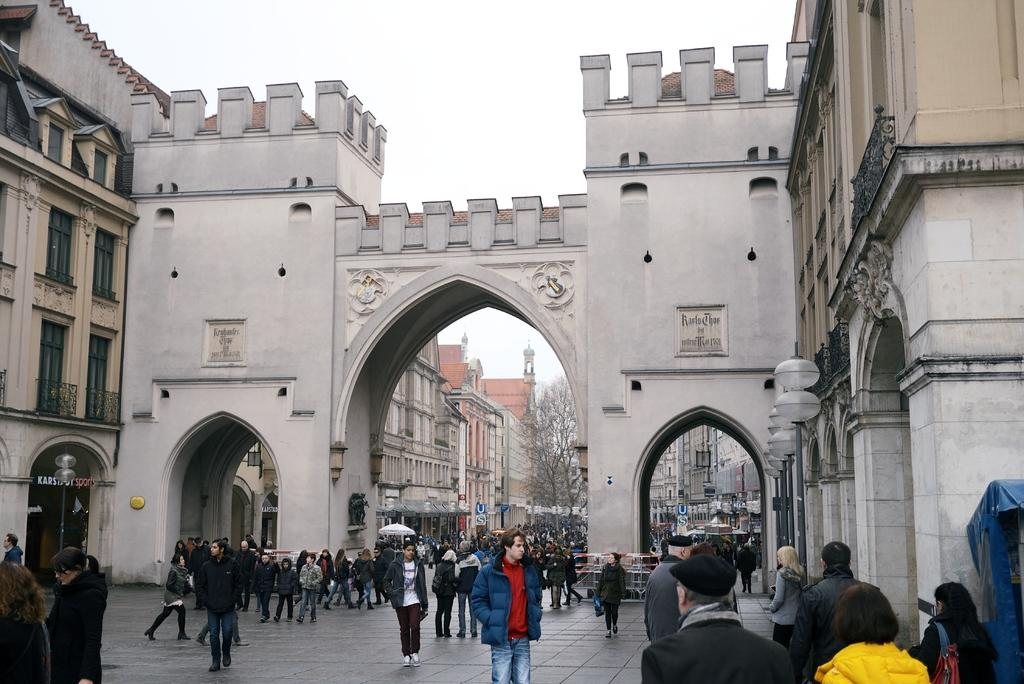What is the main subject of the image? The main subject of the image is a group of people on the ground. What can be seen in the background of the image? Buildings, trees, and the sky are visible in the background of the image. Are there any objects present in the image? Yes, there are some objects in the image. What type of verse is being recited by the people in the image? There is no indication in the image that the people are reciting any verse, so it cannot be determined from the picture. 